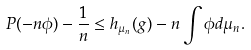<formula> <loc_0><loc_0><loc_500><loc_500>P ( - n \phi ) - \frac { 1 } { n } \leq h _ { \mu _ { n } } ( g ) - n \int \phi d \mu _ { n } .</formula> 